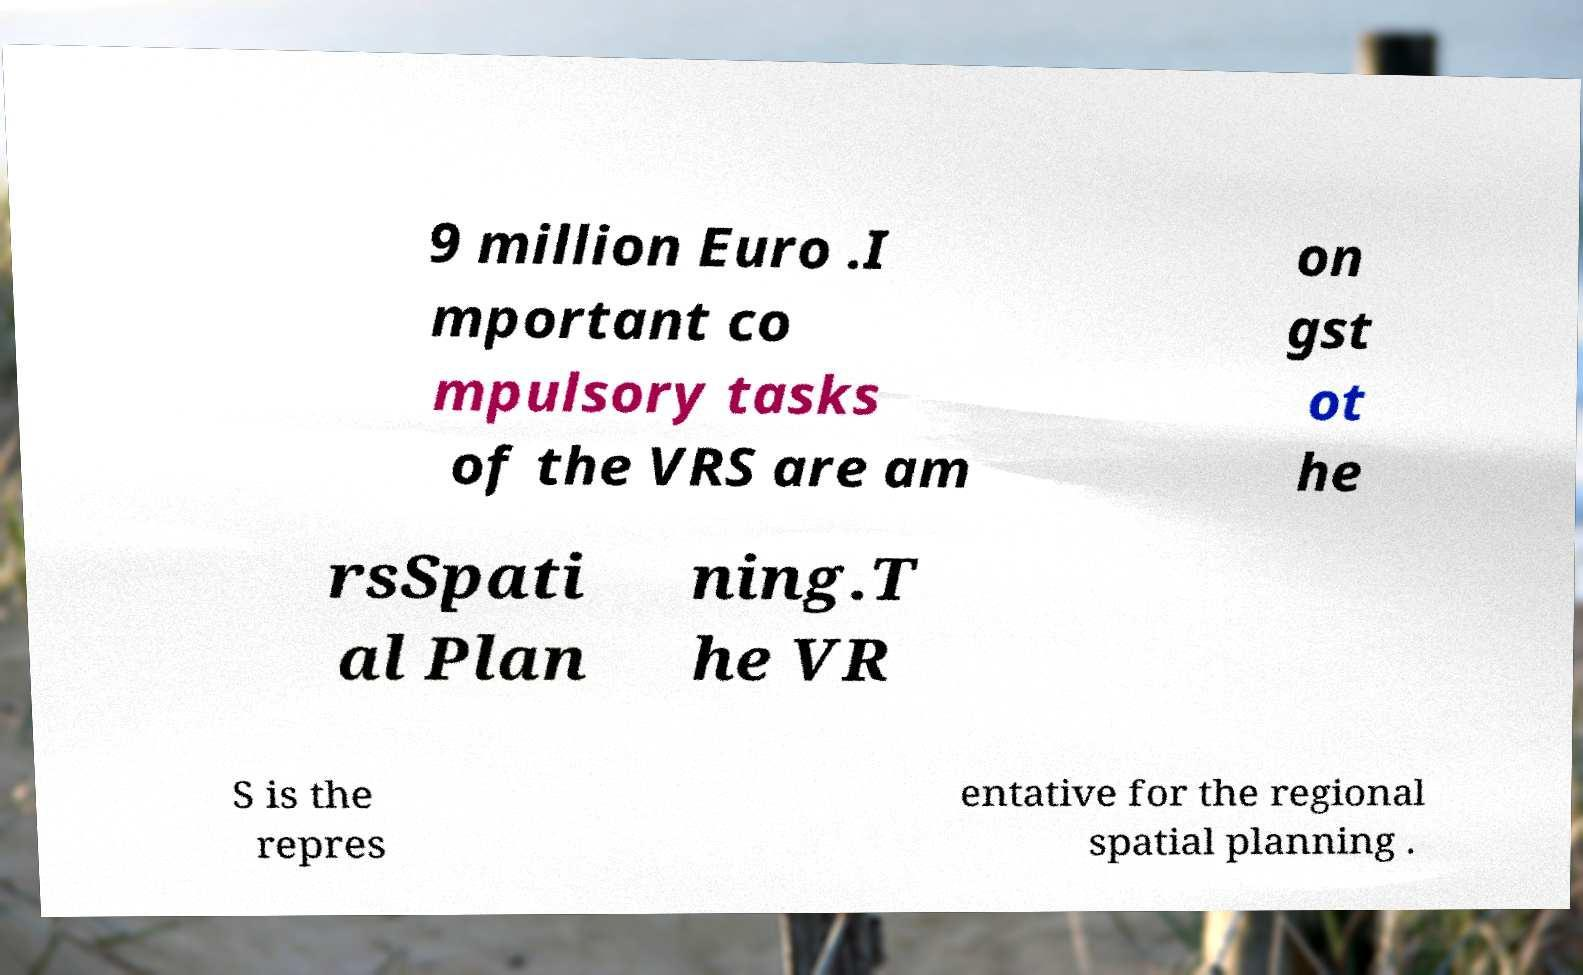Can you accurately transcribe the text from the provided image for me? 9 million Euro .I mportant co mpulsory tasks of the VRS are am on gst ot he rsSpati al Plan ning.T he VR S is the repres entative for the regional spatial planning . 